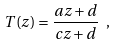<formula> <loc_0><loc_0><loc_500><loc_500>T ( z ) = \frac { a z + d } { c z + d } \ ,</formula> 